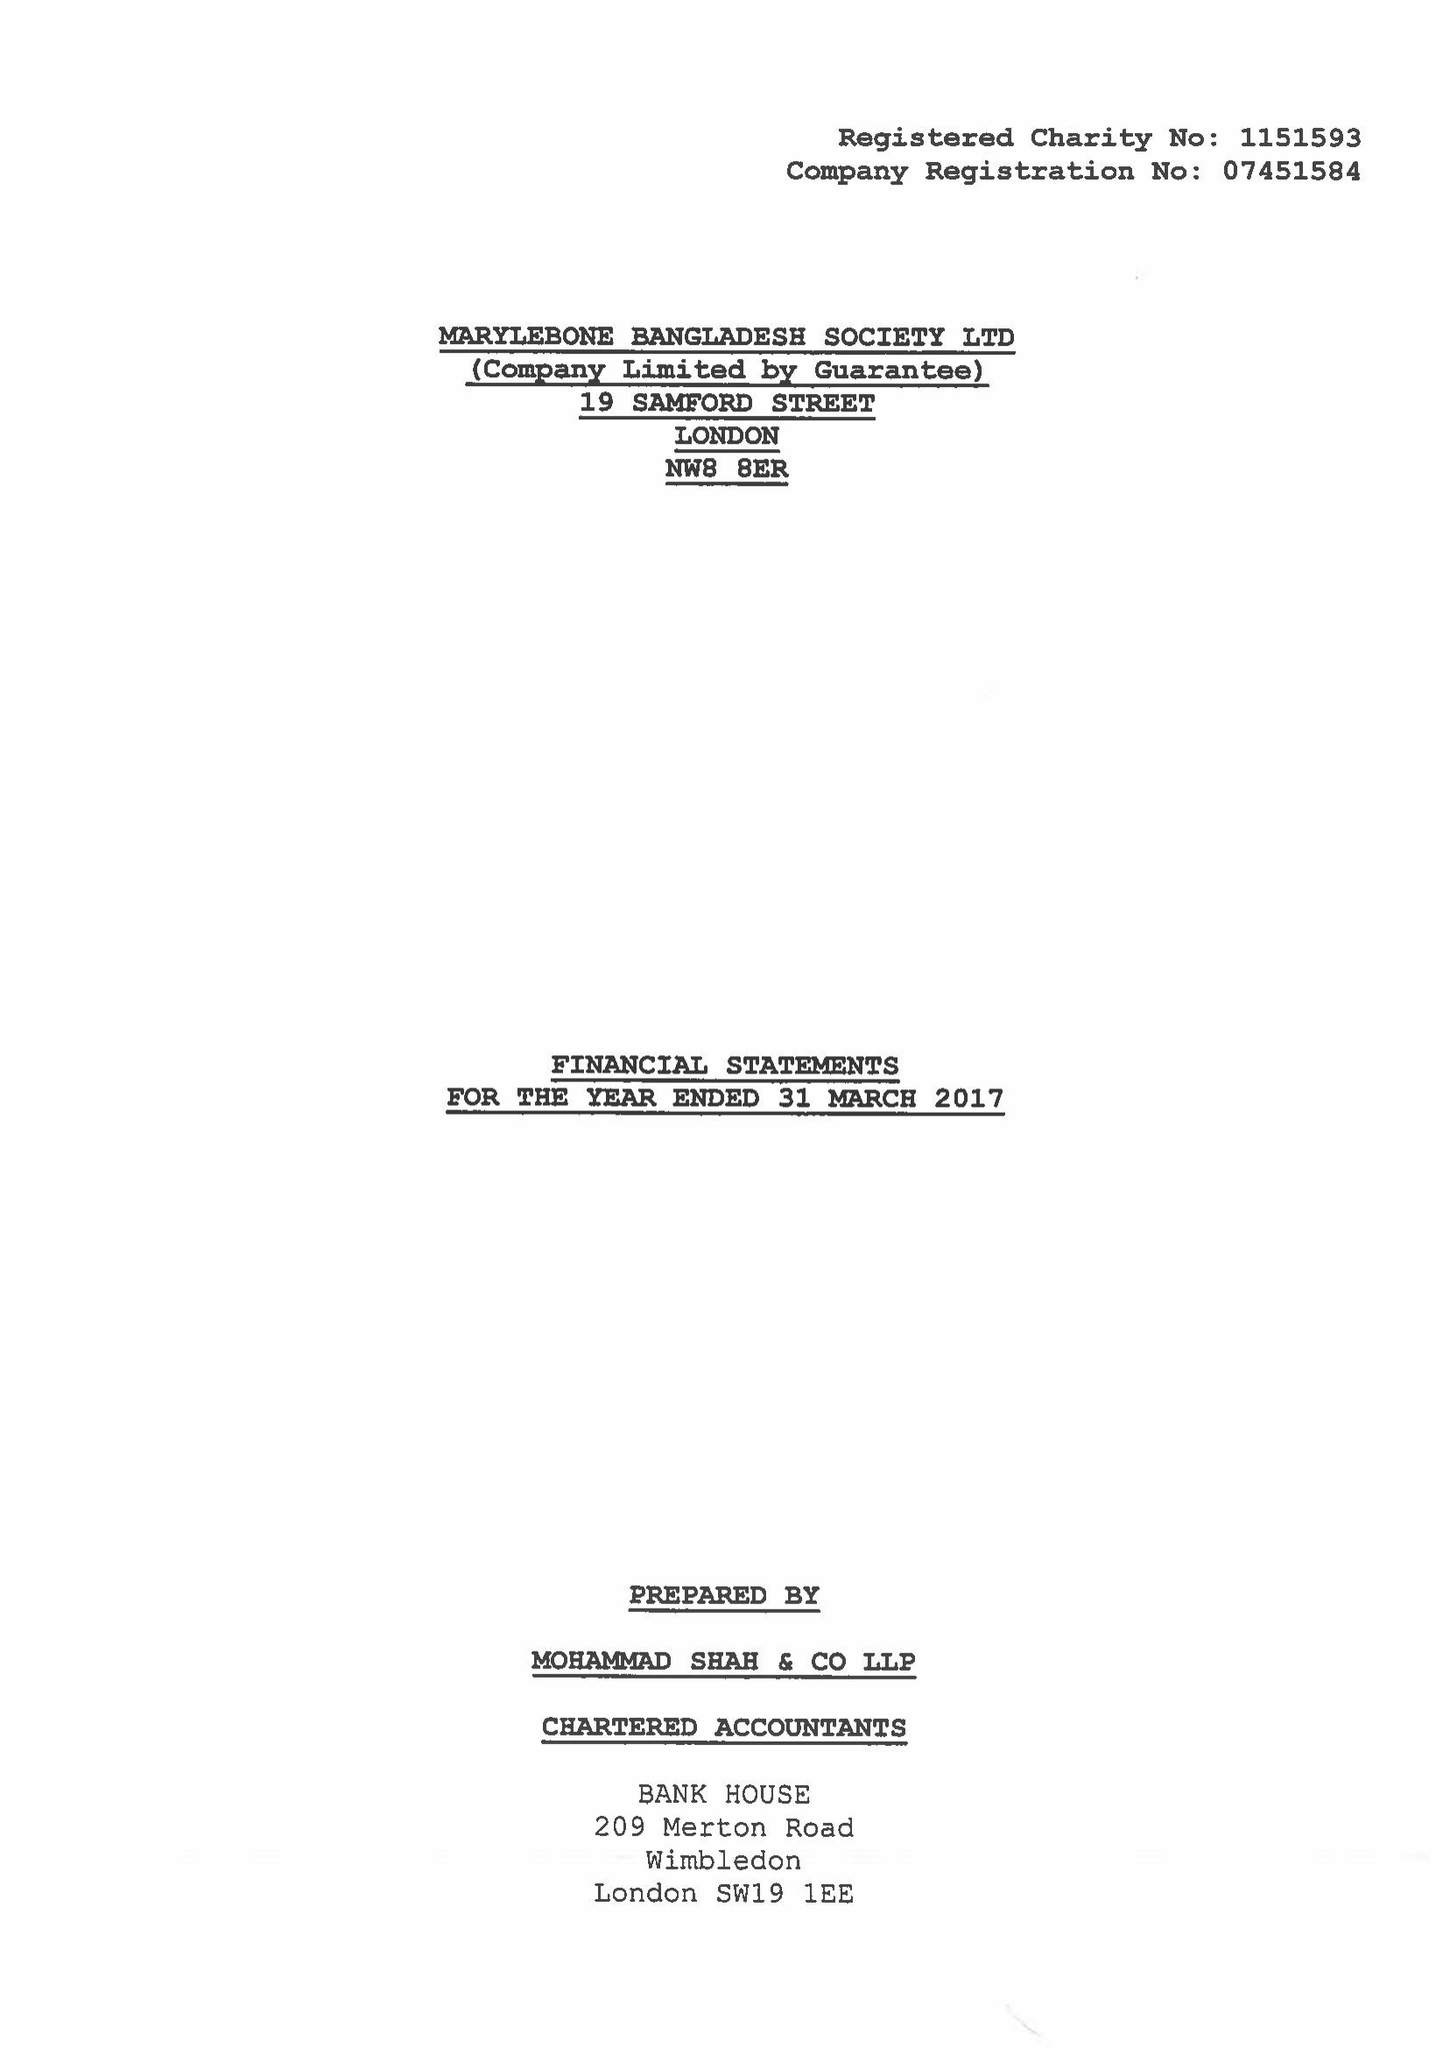What is the value for the report_date?
Answer the question using a single word or phrase. 2017-03-31 